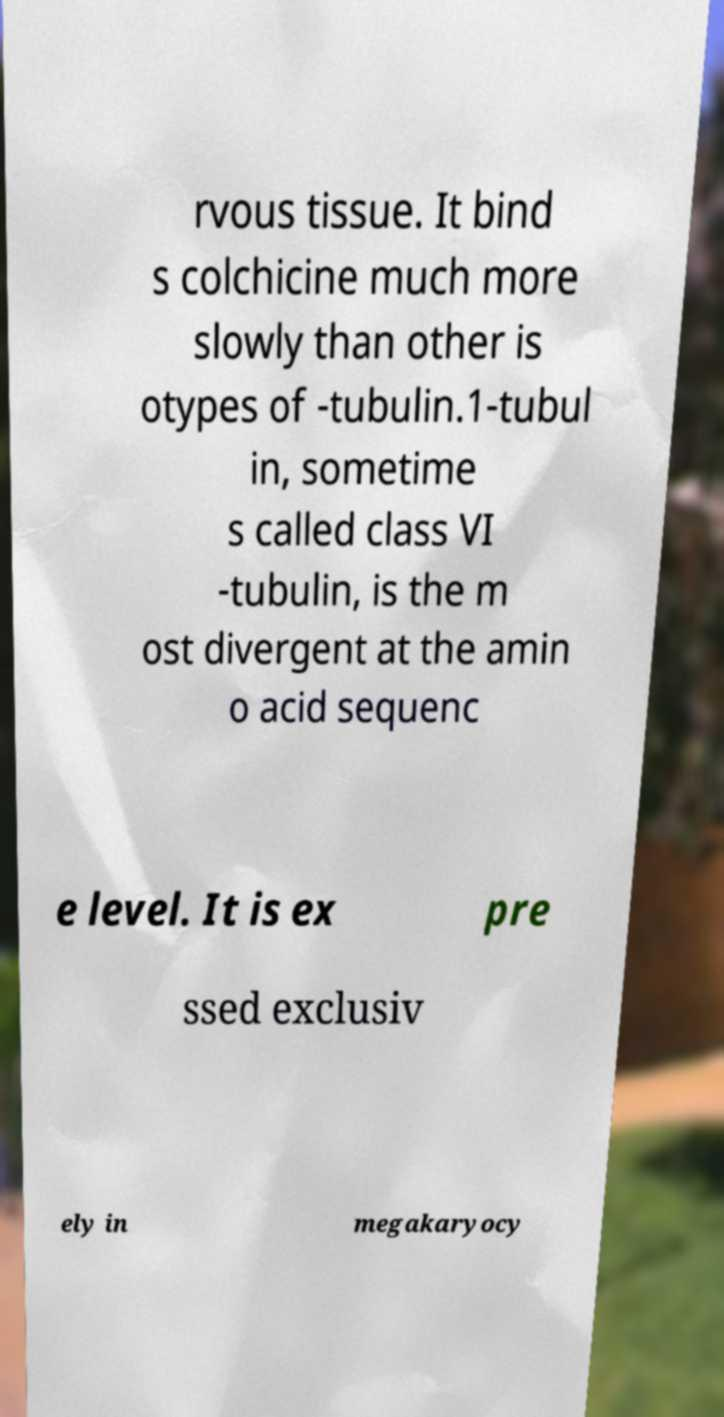Please read and relay the text visible in this image. What does it say? rvous tissue. It bind s colchicine much more slowly than other is otypes of -tubulin.1-tubul in, sometime s called class VI -tubulin, is the m ost divergent at the amin o acid sequenc e level. It is ex pre ssed exclusiv ely in megakaryocy 